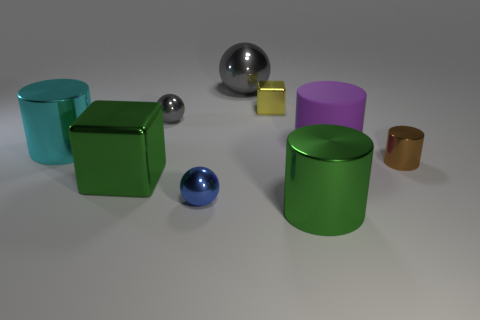The block that is to the left of the large metallic object behind the metallic cylinder that is left of the green shiny cylinder is what color?
Make the answer very short. Green. Are there any other things that have the same shape as the big purple thing?
Ensure brevity in your answer.  Yes. Is the number of tiny rubber things greater than the number of cyan metal cylinders?
Your answer should be compact. No. How many things are both in front of the big green metallic cube and to the left of the big green shiny cylinder?
Give a very brief answer. 1. What number of cyan shiny cylinders are behind the metallic block that is behind the big cyan object?
Provide a short and direct response. 0. Is the size of the metallic sphere in front of the big shiny block the same as the metal block behind the purple rubber thing?
Offer a terse response. Yes. What number of large cyan metallic cylinders are there?
Your response must be concise. 1. What number of blocks are made of the same material as the tiny gray sphere?
Offer a terse response. 2. Are there the same number of small metallic cylinders that are to the left of the matte cylinder and small brown shiny cylinders?
Your answer should be compact. No. There is a large thing that is the same color as the large shiny block; what is its material?
Your answer should be very brief. Metal. 